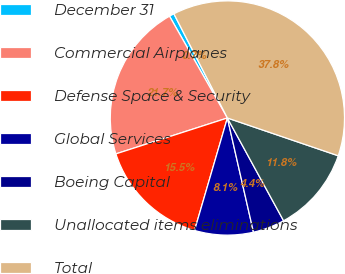Convert chart to OTSL. <chart><loc_0><loc_0><loc_500><loc_500><pie_chart><fcel>December 31<fcel>Commercial Airplanes<fcel>Defense Space & Security<fcel>Global Services<fcel>Boeing Capital<fcel>Unallocated items eliminations<fcel>Total<nl><fcel>0.68%<fcel>21.73%<fcel>15.52%<fcel>8.1%<fcel>4.39%<fcel>11.81%<fcel>37.78%<nl></chart> 